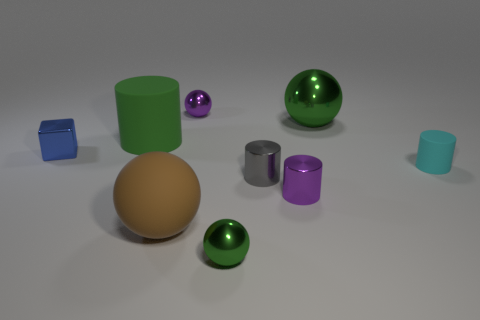Add 1 cyan blocks. How many objects exist? 10 Subtract all tiny gray cylinders. How many cylinders are left? 3 Subtract all green cylinders. How many cylinders are left? 3 Subtract all blocks. How many objects are left? 8 Add 8 green balls. How many green balls exist? 10 Subtract 0 blue cylinders. How many objects are left? 9 Subtract 2 cylinders. How many cylinders are left? 2 Subtract all purple balls. Subtract all purple cylinders. How many balls are left? 3 Subtract all yellow blocks. How many green balls are left? 2 Subtract all small cyan objects. Subtract all tiny blue metallic blocks. How many objects are left? 7 